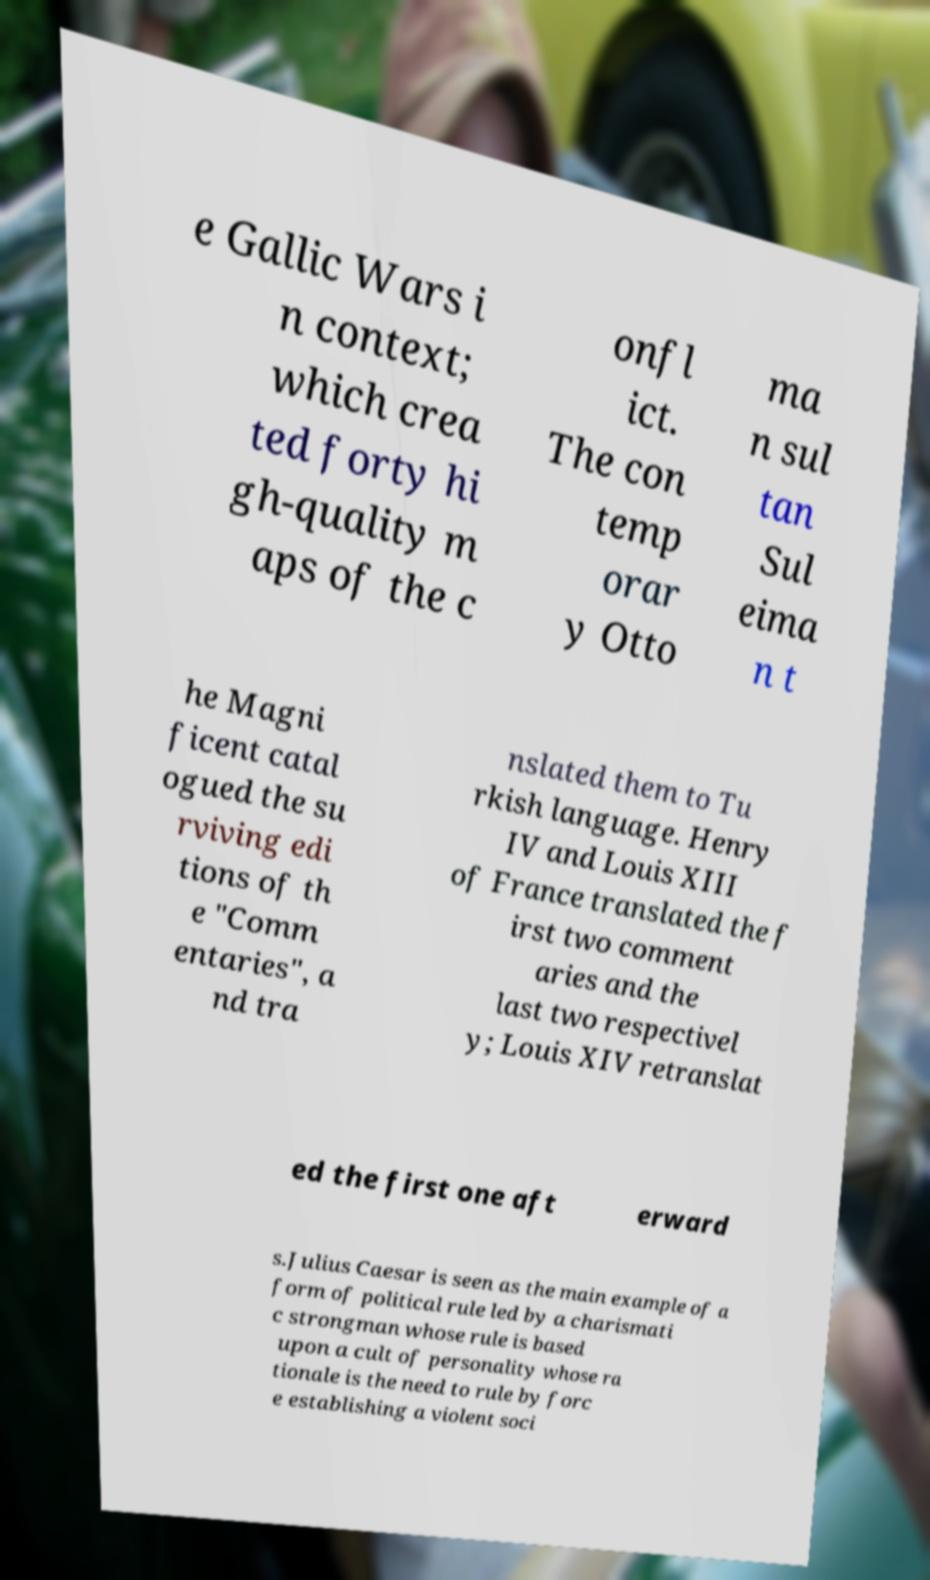Can you accurately transcribe the text from the provided image for me? e Gallic Wars i n context; which crea ted forty hi gh-quality m aps of the c onfl ict. The con temp orar y Otto ma n sul tan Sul eima n t he Magni ficent catal ogued the su rviving edi tions of th e "Comm entaries", a nd tra nslated them to Tu rkish language. Henry IV and Louis XIII of France translated the f irst two comment aries and the last two respectivel y; Louis XIV retranslat ed the first one aft erward s.Julius Caesar is seen as the main example of a form of political rule led by a charismati c strongman whose rule is based upon a cult of personality whose ra tionale is the need to rule by forc e establishing a violent soci 